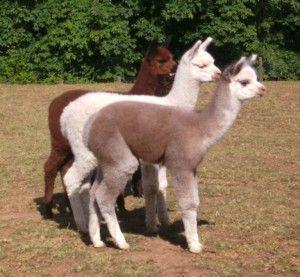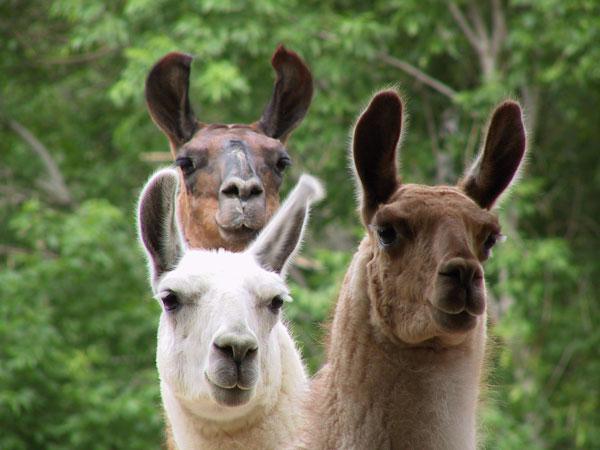The first image is the image on the left, the second image is the image on the right. Given the left and right images, does the statement "The left image contains one standing brown-and-white llama, and the right image contains at least two all white llamas." hold true? Answer yes or no. No. The first image is the image on the left, the second image is the image on the right. For the images displayed, is the sentence "There are four llamas." factually correct? Answer yes or no. No. 